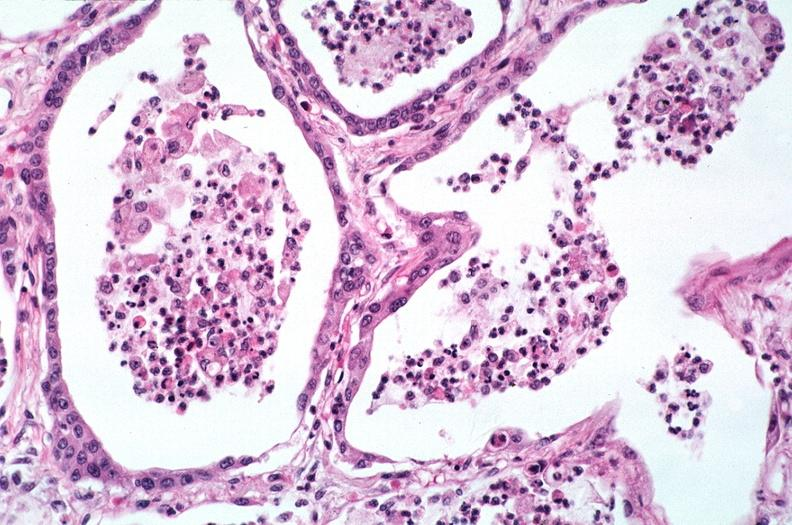what is present?
Answer the question using a single word or phrase. Respiratory 